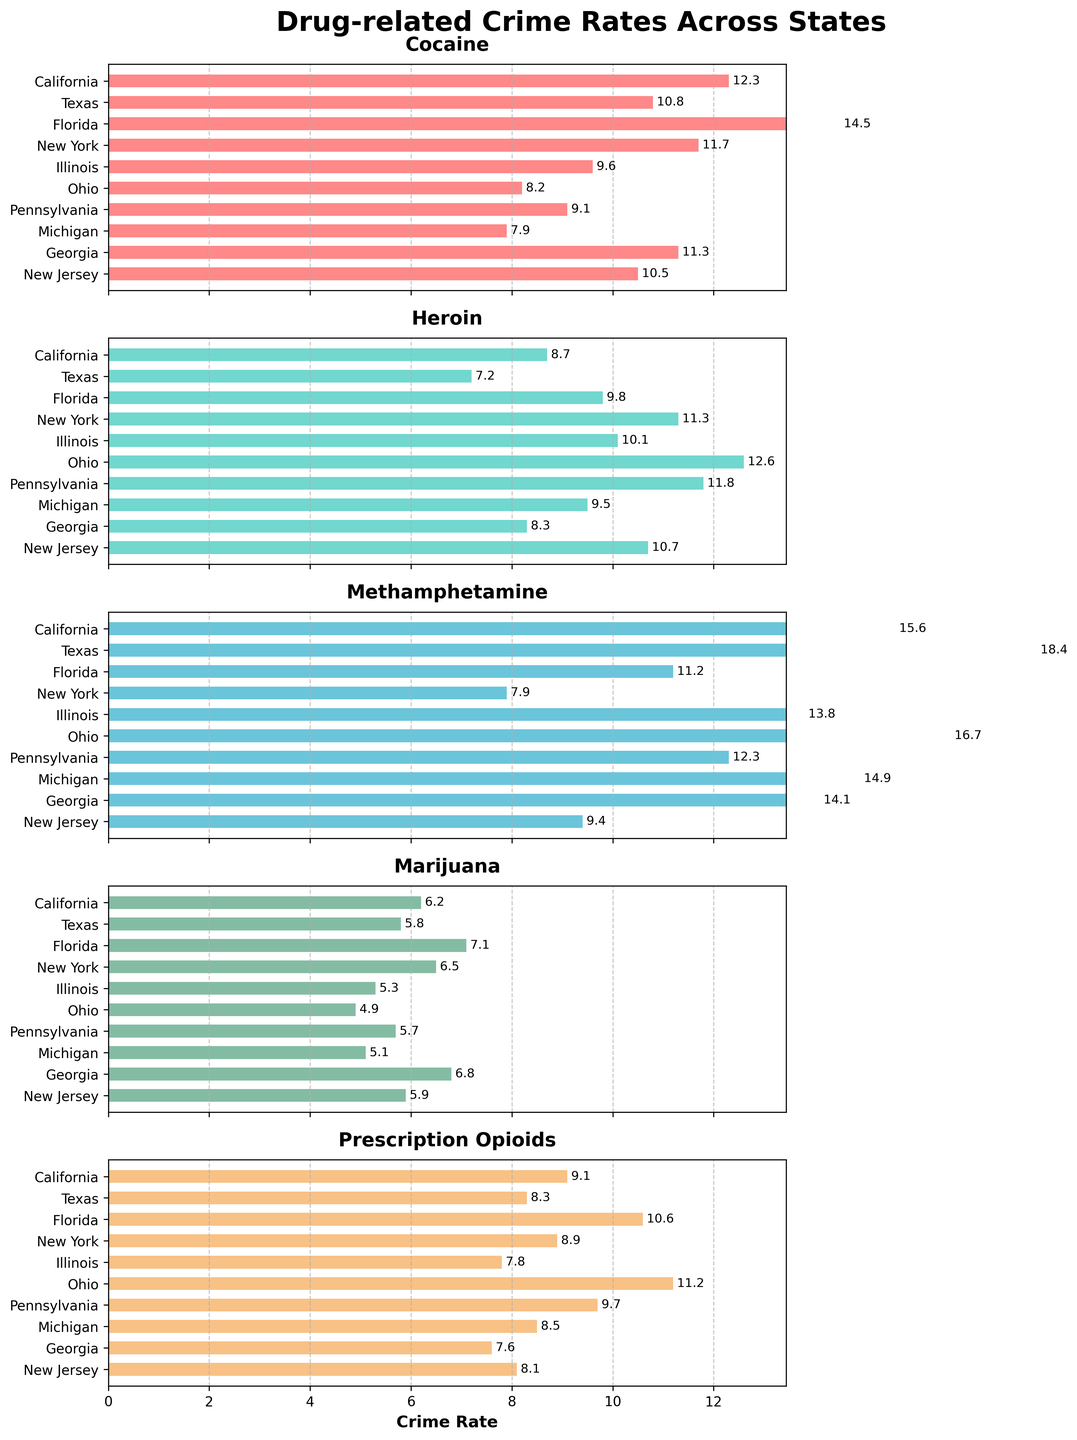What is the highest crime rate for Cocaine? Look at the Cocaine subplot and identify the highest bar. The bar corresponding to Florida has the highest value of 14.5.
Answer: 14.5 Which state has the lowest crime rate for Methamphetamine? Look at the Methamphetamine subplot and compare the bar lengths. New York has the shortest bar with a value of 7.9.
Answer: New York What is the average crime rate for Heroin across all states? Sum the Heroin crime rates for all states and divide by the number of states (9.8+7.2+11.3+10.1+12.6+11.8+9.5+8.3+10.7 = 91.3, then 91.3/10).
Answer: 9.13 Which state has the highest total drug-related crime rate across all categories? Sum all the drug-related crime rates for each state and compare them. Florida has the highest total (14.5 + 9.8 + 11.2 + 7.1 + 10.6 = 53.2).
Answer: Florida How does California's crime rate for Methamphetamine compare to Texas's? Compare the Methamphetamine bars for California and Texas. California has a crime rate of 15.6, and Texas has 18.4, so Texas is higher.
Answer: Texas is higher Which drug type has the highest crime rate in Ohio? Look at the Ohio row in all subplots and find the highest value. Methamphetamine has the highest rate at 16.7.
Answer: Methamphetamine What's the median crime rate for Prescription Opioids across all states? List the crime rates for Prescription Opioids in ascending order and find the middle value. The rates are 7.6, 7.8, 8.1, 8.3, 8.5, 8.9, 9.1, 9.7, 10.6, 11.2. The median is the average of the middle two values, (8.5 + 8.9) / 2.
Answer: 8.7 Is the crime rate for Marijuana higher in Georgia or Michigan? Compare the Marijuana bars for Georgia (6.8) and Michigan (5.1). Georgia's crime rate is higher.
Answer: Georgia What are the states with a crime rate above 10 for Cocaine? Identify the states with Cocaine crime rates above 10: California (12.3), Florida (14.5), Georgia (11.3), New York (11.7), and Texas (10.8).
Answer: California, Florida, Georgia, New York, Texas 